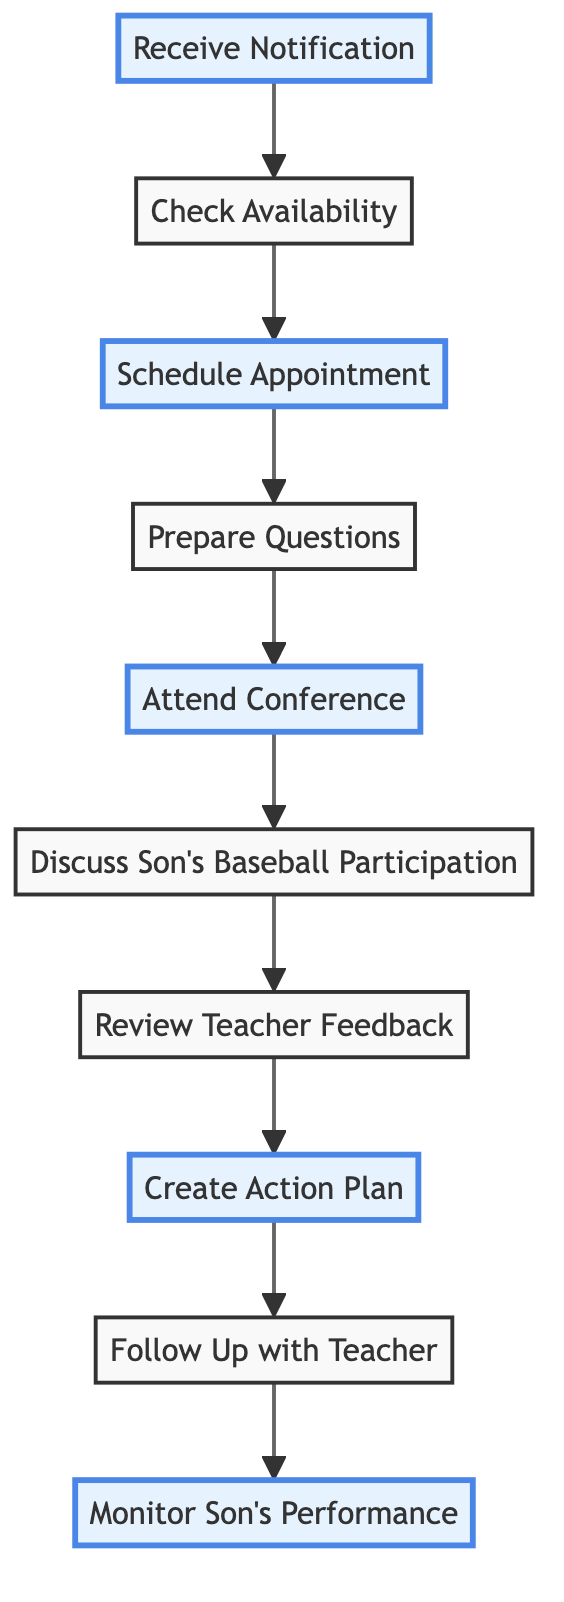What is the first step in the flow chart? The first step is "Receive Notification," as it is the starting point of the process.
Answer: Receive Notification How many steps are in the flow chart? There are 10 steps in total as counted from the nodes in the diagram.
Answer: 10 What is the last action in the process? The last action is "Monitor Son’s Performance," as it is the final node in the flow chart.
Answer: Monitor Son’s Performance What follows after "Attend Conference"? After "Attend Conference," the next step is "Discuss Son's Baseball Participation." This shows the sequence in which these actions occur.
Answer: Discuss Son's Baseball Participation Which step involves checking the calendar? The step that involves checking the calendar is "Check Availability," which precedes scheduling the appointment.
Answer: Check Availability What actions are specifically highlighted in the diagram? The highlighted actions in the diagram include "Receive Notification," "Schedule Appointment," "Attend Conference," "Create Action Plan," and "Monitor Son’s Performance." These indicate key points in the process.
Answer: Receive Notification, Schedule Appointment, Attend Conference, Create Action Plan, Monitor Son’s Performance How does "Create Action Plan" relate to "Review Teacher Feedback"? "Create Action Plan" follows "Review Teacher Feedback," indicating that the creation of the action plan is based on reflecting on the teacher's comments and suggestions.
Answer: It follows What is the purpose of the step "Follow Up with Teacher"? The purpose of "Follow Up with Teacher" is to establish communication for monitoring the son’s progress and addressing any new concerns that may arise after the conference.
Answer: Establish communication What do you do before "Attend Conference"? Before "Attend Conference," you need to "Prepare Questions," which involves gathering concerns or topics to discuss during the meeting.
Answer: Prepare Questions Which step emphasizes the academic and behavioral goal setting? The step that emphasizes academic and behavioral goal setting is "Create Action Plan," where specific goals are established based on insights from the conference.
Answer: Create Action Plan 